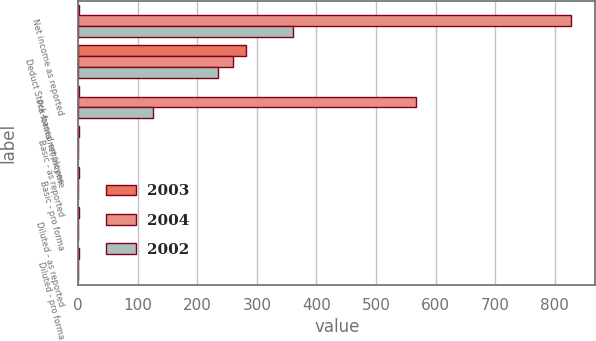Convert chart to OTSL. <chart><loc_0><loc_0><loc_500><loc_500><stacked_bar_chart><ecel><fcel>Net income as reported<fcel>Deduct Stock-based employee<fcel>Pro forma net income<fcel>Basic - as reported<fcel>Basic - pro forma<fcel>Diluted - as reported<fcel>Diluted - pro forma<nl><fcel>2003<fcel>0.89<fcel>281<fcel>0.89<fcel>1.06<fcel>0.89<fcel>1.03<fcel>0.86<nl><fcel>2004<fcel>827<fcel>260<fcel>568<fcel>0.52<fcel>0.36<fcel>0.51<fcel>0.35<nl><fcel>2002<fcel>360<fcel>235<fcel>126<fcel>0.23<fcel>0.08<fcel>0.22<fcel>0.08<nl></chart> 